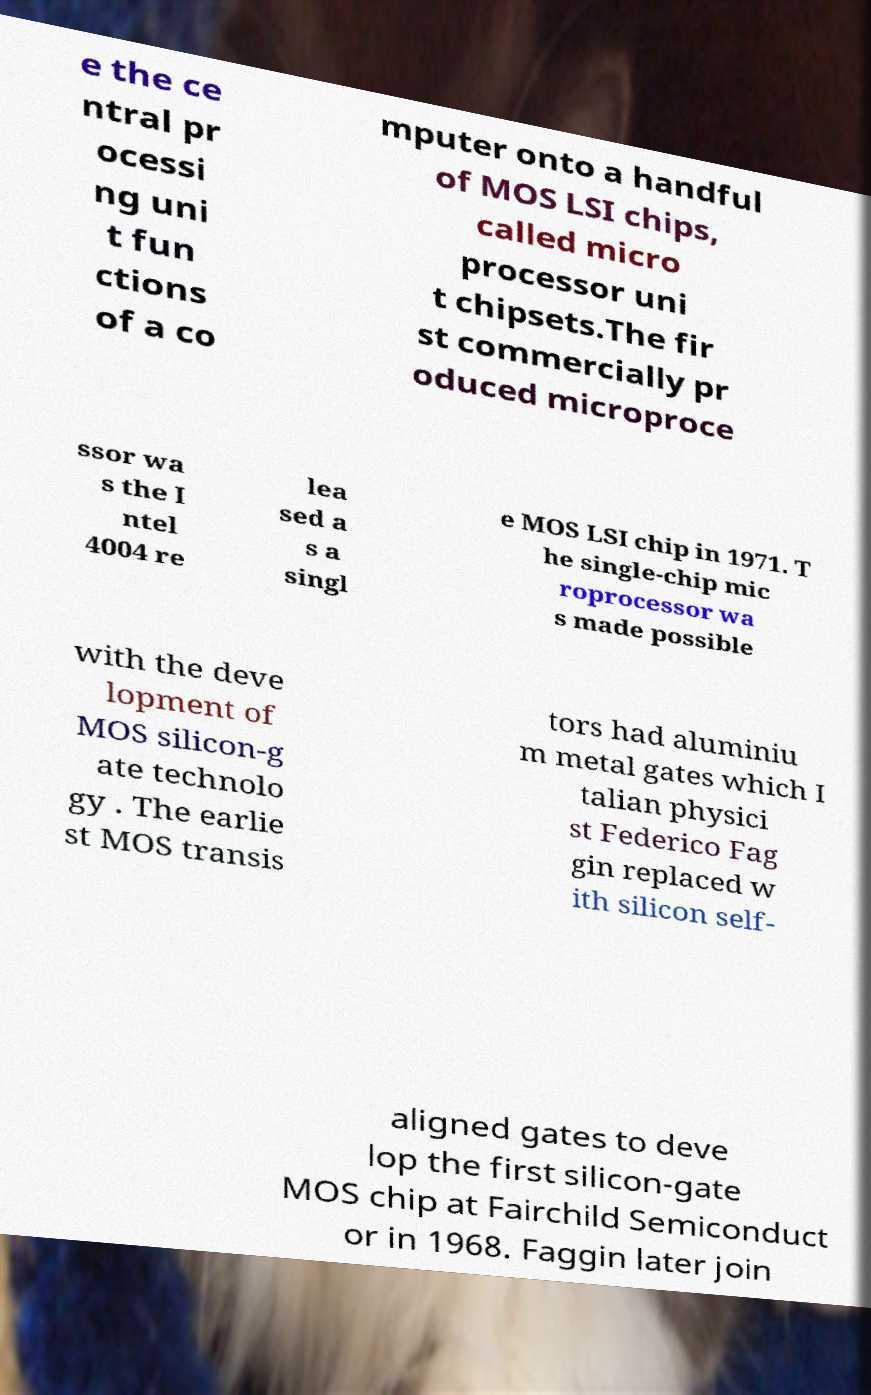Could you assist in decoding the text presented in this image and type it out clearly? e the ce ntral pr ocessi ng uni t fun ctions of a co mputer onto a handful of MOS LSI chips, called micro processor uni t chipsets.The fir st commercially pr oduced microproce ssor wa s the I ntel 4004 re lea sed a s a singl e MOS LSI chip in 1971. T he single-chip mic roprocessor wa s made possible with the deve lopment of MOS silicon-g ate technolo gy . The earlie st MOS transis tors had aluminiu m metal gates which I talian physici st Federico Fag gin replaced w ith silicon self- aligned gates to deve lop the first silicon-gate MOS chip at Fairchild Semiconduct or in 1968. Faggin later join 